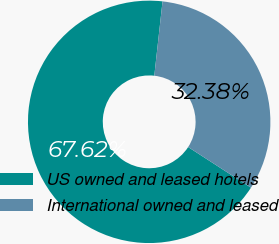Convert chart to OTSL. <chart><loc_0><loc_0><loc_500><loc_500><pie_chart><fcel>US owned and leased hotels<fcel>International owned and leased<nl><fcel>67.62%<fcel>32.38%<nl></chart> 